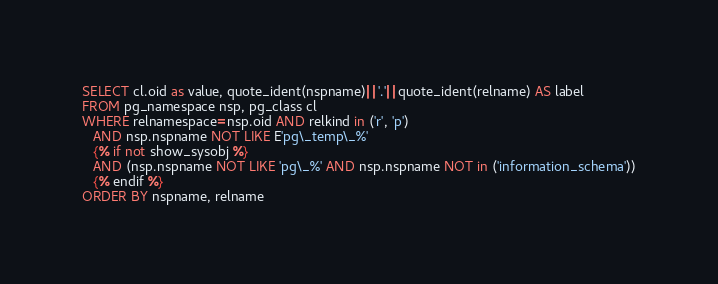<code> <loc_0><loc_0><loc_500><loc_500><_SQL_>SELECT cl.oid as value, quote_ident(nspname)||'.'||quote_ident(relname) AS label
FROM pg_namespace nsp, pg_class cl
WHERE relnamespace=nsp.oid AND relkind in ('r', 'p')
   AND nsp.nspname NOT LIKE E'pg\_temp\_%'
   {% if not show_sysobj %}
   AND (nsp.nspname NOT LIKE 'pg\_%' AND nsp.nspname NOT in ('information_schema'))
   {% endif %}
ORDER BY nspname, relname
</code> 